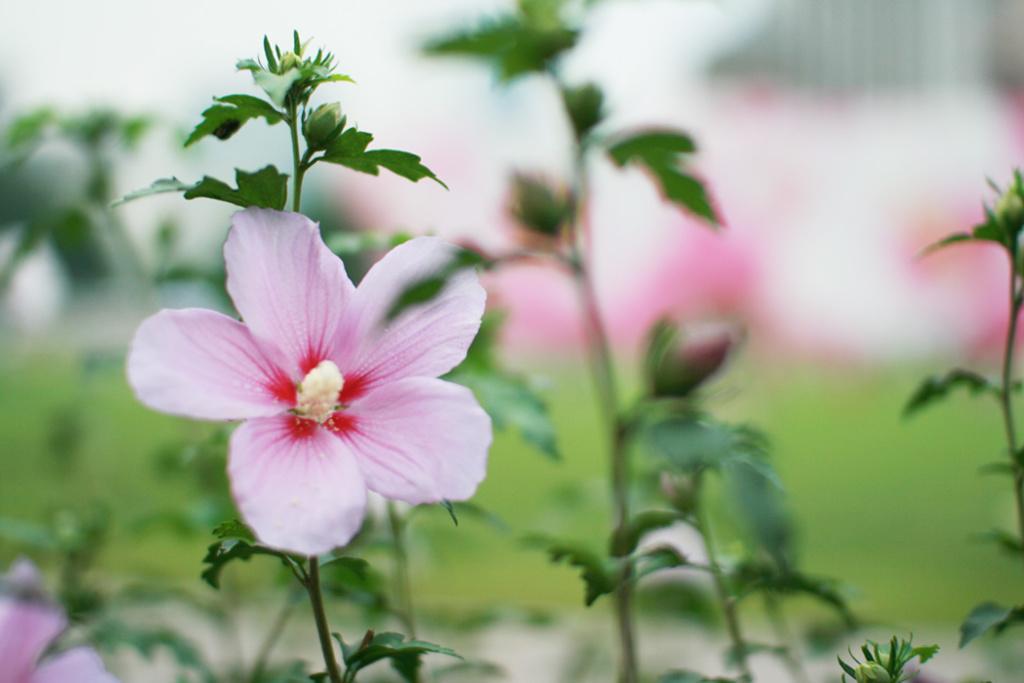Can you describe this image briefly? In this image we can see plants and flowers. The background of the image is blurred. 